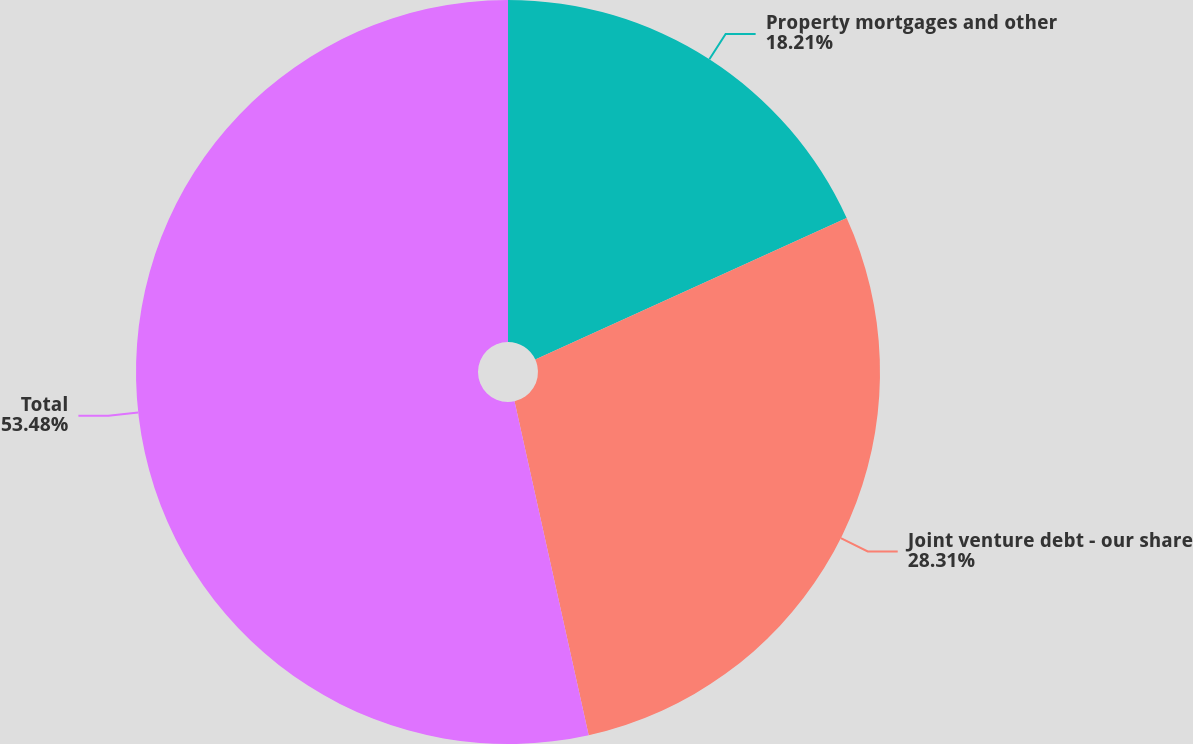<chart> <loc_0><loc_0><loc_500><loc_500><pie_chart><fcel>Property mortgages and other<fcel>Joint venture debt - our share<fcel>Total<nl><fcel>18.21%<fcel>28.31%<fcel>53.48%<nl></chart> 